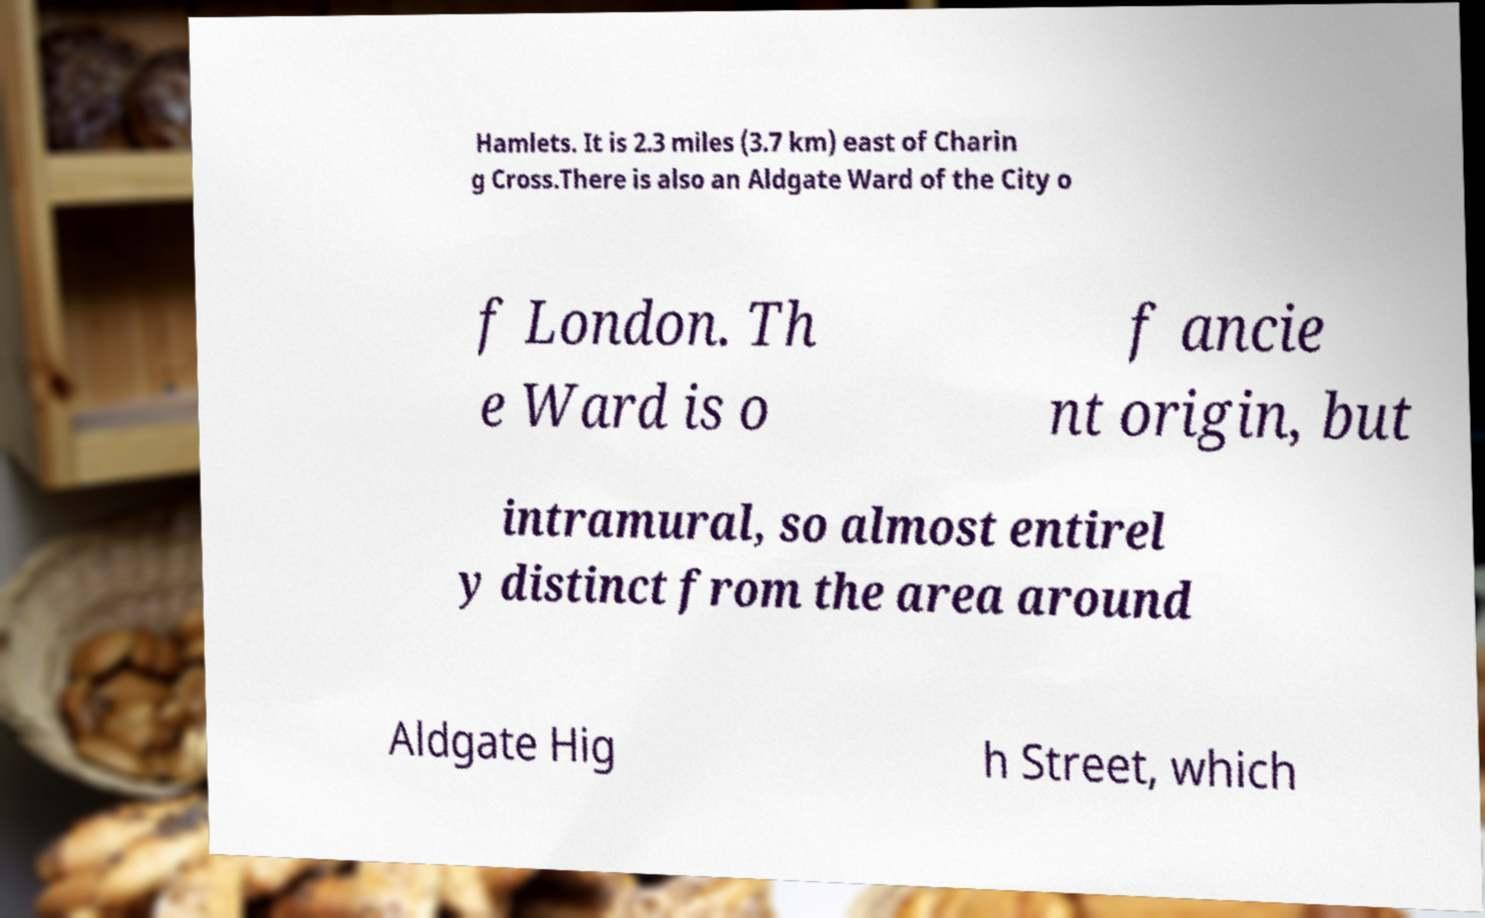For documentation purposes, I need the text within this image transcribed. Could you provide that? Hamlets. It is 2.3 miles (3.7 km) east of Charin g Cross.There is also an Aldgate Ward of the City o f London. Th e Ward is o f ancie nt origin, but intramural, so almost entirel y distinct from the area around Aldgate Hig h Street, which 